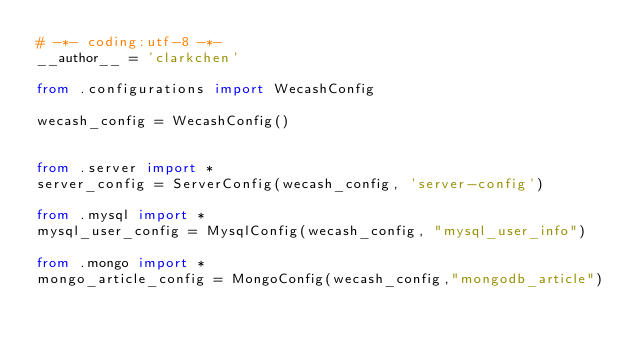<code> <loc_0><loc_0><loc_500><loc_500><_Python_># -*- coding:utf-8 -*-
__author__ = 'clarkchen'

from .configurations import WecashConfig

wecash_config = WecashConfig()


from .server import *
server_config = ServerConfig(wecash_config, 'server-config')

from .mysql import *
mysql_user_config = MysqlConfig(wecash_config, "mysql_user_info")

from .mongo import *
mongo_article_config = MongoConfig(wecash_config,"mongodb_article")
</code> 